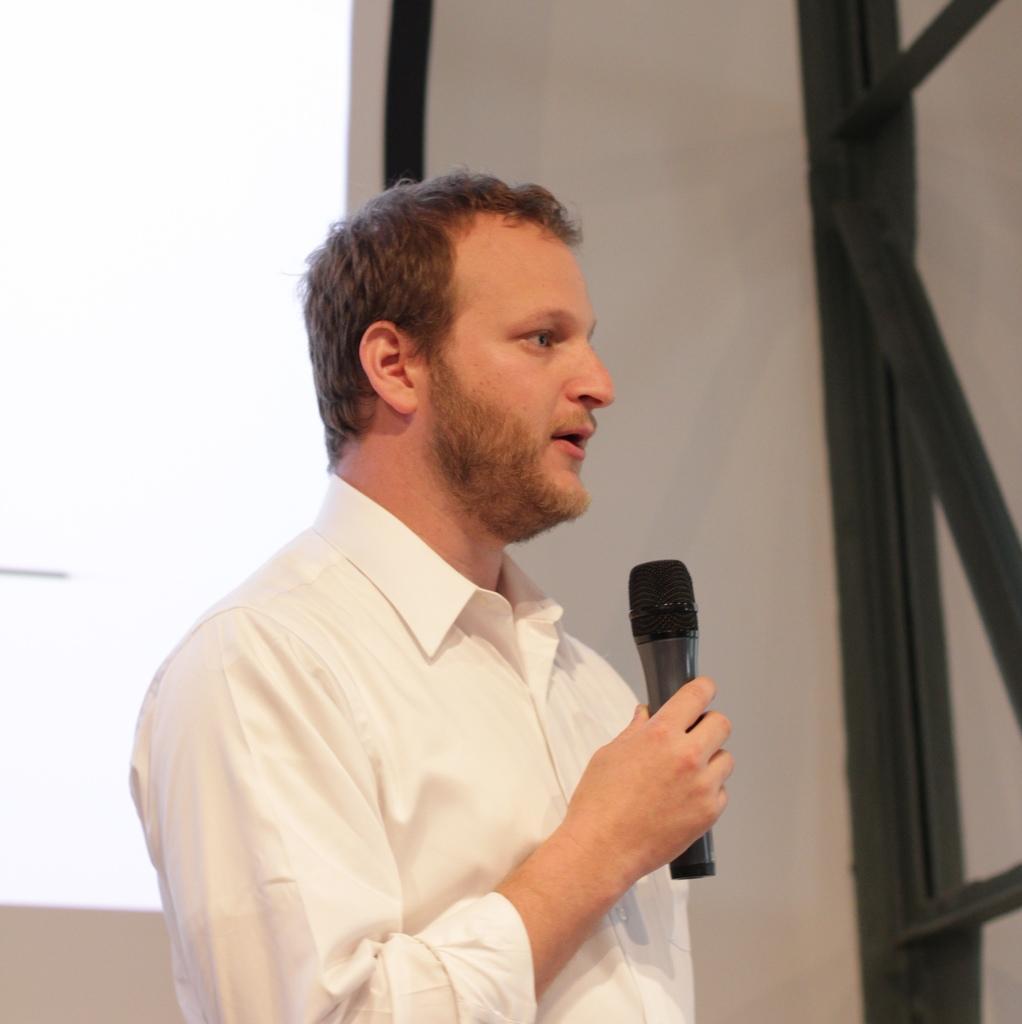Please provide a concise description of this image. In the picture there is a man standing and holding microphone in his hand. He wore a white shirt. In the background there is a wall. 